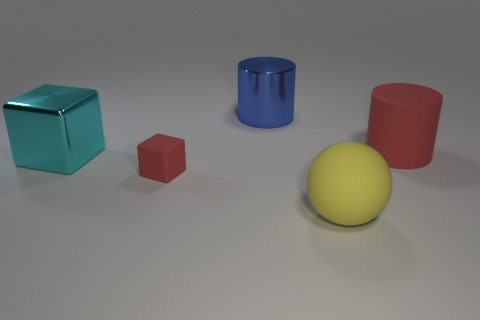Add 5 large gray things. How many objects exist? 10 Subtract all cylinders. How many objects are left? 3 Add 4 large matte things. How many large matte things exist? 6 Subtract 0 purple balls. How many objects are left? 5 Subtract all rubber cylinders. Subtract all big red objects. How many objects are left? 3 Add 1 shiny blocks. How many shiny blocks are left? 2 